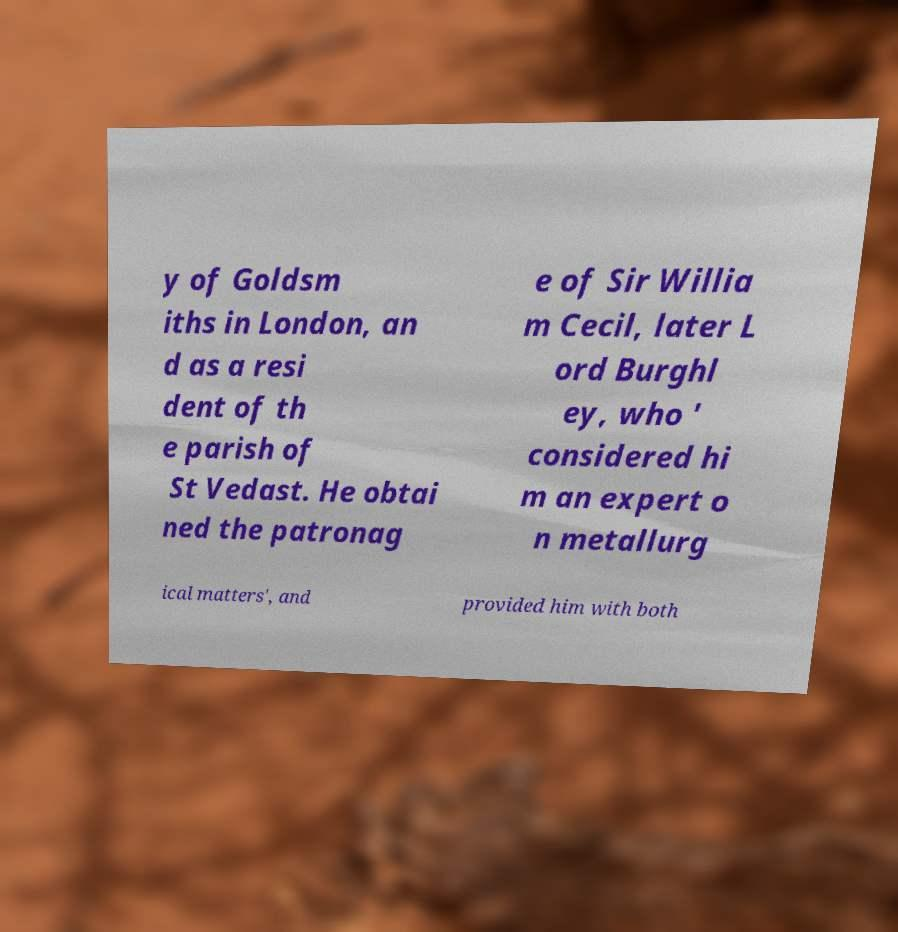Can you accurately transcribe the text from the provided image for me? y of Goldsm iths in London, an d as a resi dent of th e parish of St Vedast. He obtai ned the patronag e of Sir Willia m Cecil, later L ord Burghl ey, who ' considered hi m an expert o n metallurg ical matters', and provided him with both 